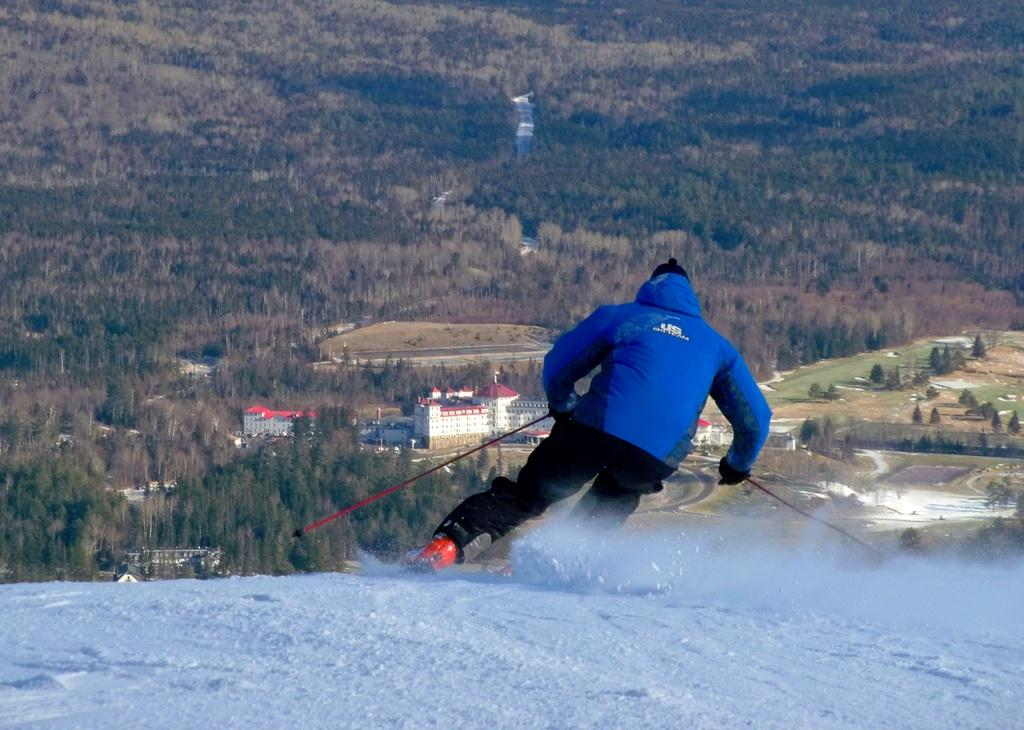What is the color of the snow in the image? The snow is white in the image. What is the person in the image doing? The person is holding ski sticks in the image. What can be seen in the background of the image? There are trees in the background of the image. What is the rate of the person's wealth in the image? There is no information about the person's wealth in the image, so it cannot be determined. 